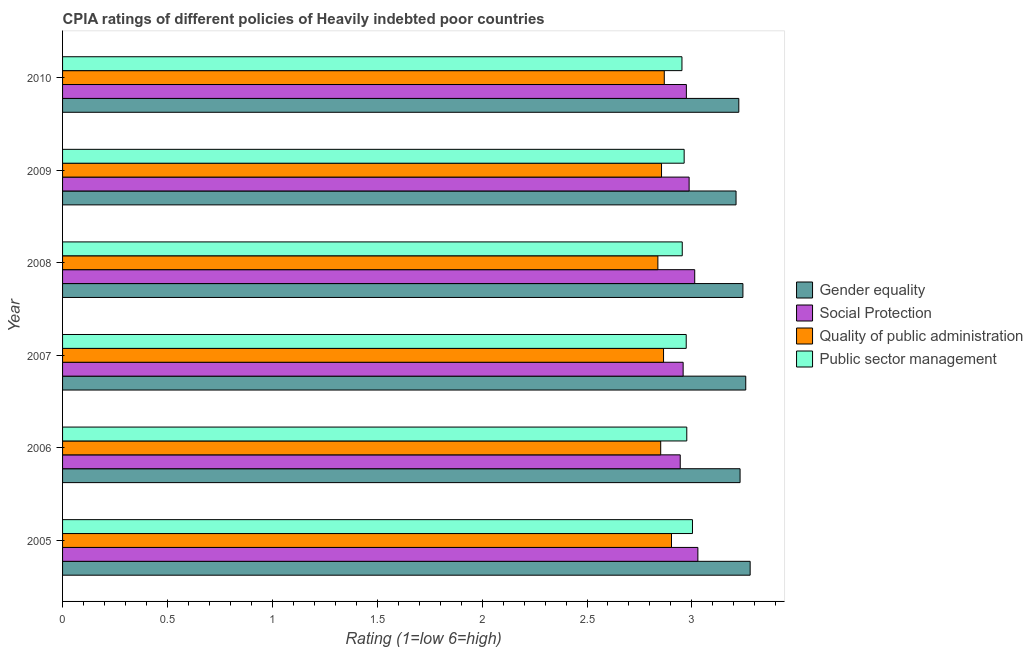How many different coloured bars are there?
Ensure brevity in your answer.  4. How many groups of bars are there?
Give a very brief answer. 6. Are the number of bars per tick equal to the number of legend labels?
Make the answer very short. Yes. How many bars are there on the 6th tick from the bottom?
Give a very brief answer. 4. What is the label of the 4th group of bars from the top?
Keep it short and to the point. 2007. In how many cases, is the number of bars for a given year not equal to the number of legend labels?
Keep it short and to the point. 0. What is the cpia rating of quality of public administration in 2010?
Ensure brevity in your answer.  2.87. Across all years, what is the maximum cpia rating of quality of public administration?
Your answer should be very brief. 2.9. Across all years, what is the minimum cpia rating of gender equality?
Your response must be concise. 3.21. In which year was the cpia rating of social protection minimum?
Give a very brief answer. 2006. What is the total cpia rating of gender equality in the graph?
Your answer should be very brief. 19.44. What is the difference between the cpia rating of quality of public administration in 2005 and that in 2008?
Keep it short and to the point. 0.07. What is the difference between the cpia rating of social protection in 2009 and the cpia rating of quality of public administration in 2005?
Offer a very short reply. 0.08. What is the average cpia rating of social protection per year?
Offer a very short reply. 2.98. In the year 2009, what is the difference between the cpia rating of gender equality and cpia rating of social protection?
Provide a succinct answer. 0.22. Is the difference between the cpia rating of gender equality in 2007 and 2010 greater than the difference between the cpia rating of public sector management in 2007 and 2010?
Your answer should be compact. Yes. What is the difference between the highest and the second highest cpia rating of social protection?
Offer a terse response. 0.01. In how many years, is the cpia rating of social protection greater than the average cpia rating of social protection taken over all years?
Give a very brief answer. 3. Is the sum of the cpia rating of quality of public administration in 2007 and 2009 greater than the maximum cpia rating of gender equality across all years?
Ensure brevity in your answer.  Yes. Is it the case that in every year, the sum of the cpia rating of gender equality and cpia rating of social protection is greater than the sum of cpia rating of public sector management and cpia rating of quality of public administration?
Offer a terse response. Yes. What does the 4th bar from the top in 2010 represents?
Your answer should be compact. Gender equality. What does the 1st bar from the bottom in 2005 represents?
Provide a succinct answer. Gender equality. How many bars are there?
Offer a very short reply. 24. Does the graph contain grids?
Keep it short and to the point. No. What is the title of the graph?
Keep it short and to the point. CPIA ratings of different policies of Heavily indebted poor countries. Does "Tracking ability" appear as one of the legend labels in the graph?
Your answer should be very brief. No. What is the label or title of the Y-axis?
Ensure brevity in your answer.  Year. What is the Rating (1=low 6=high) in Gender equality in 2005?
Your response must be concise. 3.28. What is the Rating (1=low 6=high) in Social Protection in 2005?
Your response must be concise. 3.03. What is the Rating (1=low 6=high) in Quality of public administration in 2005?
Provide a succinct answer. 2.9. What is the Rating (1=low 6=high) of Public sector management in 2005?
Keep it short and to the point. 3. What is the Rating (1=low 6=high) of Gender equality in 2006?
Provide a succinct answer. 3.23. What is the Rating (1=low 6=high) in Social Protection in 2006?
Your response must be concise. 2.94. What is the Rating (1=low 6=high) in Quality of public administration in 2006?
Offer a very short reply. 2.85. What is the Rating (1=low 6=high) of Public sector management in 2006?
Make the answer very short. 2.98. What is the Rating (1=low 6=high) in Gender equality in 2007?
Your answer should be very brief. 3.26. What is the Rating (1=low 6=high) of Social Protection in 2007?
Your answer should be very brief. 2.96. What is the Rating (1=low 6=high) of Quality of public administration in 2007?
Offer a very short reply. 2.86. What is the Rating (1=low 6=high) in Public sector management in 2007?
Your response must be concise. 2.97. What is the Rating (1=low 6=high) in Gender equality in 2008?
Provide a short and direct response. 3.24. What is the Rating (1=low 6=high) in Social Protection in 2008?
Offer a terse response. 3.01. What is the Rating (1=low 6=high) of Quality of public administration in 2008?
Give a very brief answer. 2.84. What is the Rating (1=low 6=high) in Public sector management in 2008?
Offer a terse response. 2.95. What is the Rating (1=low 6=high) in Gender equality in 2009?
Keep it short and to the point. 3.21. What is the Rating (1=low 6=high) of Social Protection in 2009?
Your answer should be very brief. 2.99. What is the Rating (1=low 6=high) in Quality of public administration in 2009?
Offer a terse response. 2.86. What is the Rating (1=low 6=high) in Public sector management in 2009?
Make the answer very short. 2.96. What is the Rating (1=low 6=high) in Gender equality in 2010?
Offer a terse response. 3.22. What is the Rating (1=low 6=high) in Social Protection in 2010?
Offer a very short reply. 2.97. What is the Rating (1=low 6=high) in Quality of public administration in 2010?
Provide a succinct answer. 2.87. What is the Rating (1=low 6=high) in Public sector management in 2010?
Ensure brevity in your answer.  2.95. Across all years, what is the maximum Rating (1=low 6=high) in Gender equality?
Ensure brevity in your answer.  3.28. Across all years, what is the maximum Rating (1=low 6=high) in Social Protection?
Provide a short and direct response. 3.03. Across all years, what is the maximum Rating (1=low 6=high) in Quality of public administration?
Provide a succinct answer. 2.9. Across all years, what is the maximum Rating (1=low 6=high) in Public sector management?
Provide a succinct answer. 3. Across all years, what is the minimum Rating (1=low 6=high) of Gender equality?
Make the answer very short. 3.21. Across all years, what is the minimum Rating (1=low 6=high) of Social Protection?
Your answer should be compact. 2.94. Across all years, what is the minimum Rating (1=low 6=high) in Quality of public administration?
Your answer should be very brief. 2.84. Across all years, what is the minimum Rating (1=low 6=high) of Public sector management?
Your answer should be very brief. 2.95. What is the total Rating (1=low 6=high) in Gender equality in the graph?
Offer a very short reply. 19.44. What is the total Rating (1=low 6=high) of Social Protection in the graph?
Ensure brevity in your answer.  17.91. What is the total Rating (1=low 6=high) in Quality of public administration in the graph?
Offer a terse response. 17.18. What is the total Rating (1=low 6=high) of Public sector management in the graph?
Offer a very short reply. 17.82. What is the difference between the Rating (1=low 6=high) in Gender equality in 2005 and that in 2006?
Give a very brief answer. 0.05. What is the difference between the Rating (1=low 6=high) of Social Protection in 2005 and that in 2006?
Keep it short and to the point. 0.08. What is the difference between the Rating (1=low 6=high) in Quality of public administration in 2005 and that in 2006?
Keep it short and to the point. 0.05. What is the difference between the Rating (1=low 6=high) in Public sector management in 2005 and that in 2006?
Provide a succinct answer. 0.03. What is the difference between the Rating (1=low 6=high) of Gender equality in 2005 and that in 2007?
Provide a succinct answer. 0.02. What is the difference between the Rating (1=low 6=high) of Social Protection in 2005 and that in 2007?
Give a very brief answer. 0.07. What is the difference between the Rating (1=low 6=high) of Quality of public administration in 2005 and that in 2007?
Offer a very short reply. 0.04. What is the difference between the Rating (1=low 6=high) of Public sector management in 2005 and that in 2007?
Offer a terse response. 0.03. What is the difference between the Rating (1=low 6=high) of Gender equality in 2005 and that in 2008?
Provide a short and direct response. 0.03. What is the difference between the Rating (1=low 6=high) of Social Protection in 2005 and that in 2008?
Keep it short and to the point. 0.02. What is the difference between the Rating (1=low 6=high) of Quality of public administration in 2005 and that in 2008?
Your answer should be very brief. 0.06. What is the difference between the Rating (1=low 6=high) in Public sector management in 2005 and that in 2008?
Your response must be concise. 0.05. What is the difference between the Rating (1=low 6=high) of Gender equality in 2005 and that in 2009?
Offer a very short reply. 0.07. What is the difference between the Rating (1=low 6=high) in Social Protection in 2005 and that in 2009?
Keep it short and to the point. 0.04. What is the difference between the Rating (1=low 6=high) of Quality of public administration in 2005 and that in 2009?
Your response must be concise. 0.05. What is the difference between the Rating (1=low 6=high) in Public sector management in 2005 and that in 2009?
Provide a short and direct response. 0.04. What is the difference between the Rating (1=low 6=high) in Gender equality in 2005 and that in 2010?
Give a very brief answer. 0.05. What is the difference between the Rating (1=low 6=high) in Social Protection in 2005 and that in 2010?
Provide a short and direct response. 0.05. What is the difference between the Rating (1=low 6=high) in Quality of public administration in 2005 and that in 2010?
Ensure brevity in your answer.  0.03. What is the difference between the Rating (1=low 6=high) in Public sector management in 2005 and that in 2010?
Give a very brief answer. 0.05. What is the difference between the Rating (1=low 6=high) of Gender equality in 2006 and that in 2007?
Provide a short and direct response. -0.03. What is the difference between the Rating (1=low 6=high) in Social Protection in 2006 and that in 2007?
Your response must be concise. -0.01. What is the difference between the Rating (1=low 6=high) in Quality of public administration in 2006 and that in 2007?
Ensure brevity in your answer.  -0.01. What is the difference between the Rating (1=low 6=high) in Public sector management in 2006 and that in 2007?
Offer a terse response. 0. What is the difference between the Rating (1=low 6=high) in Gender equality in 2006 and that in 2008?
Give a very brief answer. -0.01. What is the difference between the Rating (1=low 6=high) in Social Protection in 2006 and that in 2008?
Offer a very short reply. -0.07. What is the difference between the Rating (1=low 6=high) of Quality of public administration in 2006 and that in 2008?
Offer a terse response. 0.01. What is the difference between the Rating (1=low 6=high) of Public sector management in 2006 and that in 2008?
Offer a terse response. 0.02. What is the difference between the Rating (1=low 6=high) of Gender equality in 2006 and that in 2009?
Your response must be concise. 0.02. What is the difference between the Rating (1=low 6=high) in Social Protection in 2006 and that in 2009?
Give a very brief answer. -0.04. What is the difference between the Rating (1=low 6=high) in Quality of public administration in 2006 and that in 2009?
Your response must be concise. -0. What is the difference between the Rating (1=low 6=high) of Public sector management in 2006 and that in 2009?
Keep it short and to the point. 0.01. What is the difference between the Rating (1=low 6=high) of Gender equality in 2006 and that in 2010?
Give a very brief answer. 0.01. What is the difference between the Rating (1=low 6=high) of Social Protection in 2006 and that in 2010?
Make the answer very short. -0.03. What is the difference between the Rating (1=low 6=high) in Quality of public administration in 2006 and that in 2010?
Make the answer very short. -0.02. What is the difference between the Rating (1=low 6=high) of Public sector management in 2006 and that in 2010?
Keep it short and to the point. 0.02. What is the difference between the Rating (1=low 6=high) in Gender equality in 2007 and that in 2008?
Your response must be concise. 0.01. What is the difference between the Rating (1=low 6=high) of Social Protection in 2007 and that in 2008?
Keep it short and to the point. -0.06. What is the difference between the Rating (1=low 6=high) of Quality of public administration in 2007 and that in 2008?
Ensure brevity in your answer.  0.03. What is the difference between the Rating (1=low 6=high) of Public sector management in 2007 and that in 2008?
Your answer should be compact. 0.02. What is the difference between the Rating (1=low 6=high) in Gender equality in 2007 and that in 2009?
Give a very brief answer. 0.05. What is the difference between the Rating (1=low 6=high) in Social Protection in 2007 and that in 2009?
Provide a succinct answer. -0.03. What is the difference between the Rating (1=low 6=high) of Quality of public administration in 2007 and that in 2009?
Keep it short and to the point. 0.01. What is the difference between the Rating (1=low 6=high) in Public sector management in 2007 and that in 2009?
Offer a very short reply. 0.01. What is the difference between the Rating (1=low 6=high) of Gender equality in 2007 and that in 2010?
Keep it short and to the point. 0.03. What is the difference between the Rating (1=low 6=high) in Social Protection in 2007 and that in 2010?
Make the answer very short. -0.02. What is the difference between the Rating (1=low 6=high) in Quality of public administration in 2007 and that in 2010?
Your answer should be very brief. -0. What is the difference between the Rating (1=low 6=high) of Public sector management in 2007 and that in 2010?
Your answer should be compact. 0.02. What is the difference between the Rating (1=low 6=high) in Gender equality in 2008 and that in 2009?
Offer a terse response. 0.03. What is the difference between the Rating (1=low 6=high) in Social Protection in 2008 and that in 2009?
Provide a succinct answer. 0.03. What is the difference between the Rating (1=low 6=high) in Quality of public administration in 2008 and that in 2009?
Provide a succinct answer. -0.02. What is the difference between the Rating (1=low 6=high) of Public sector management in 2008 and that in 2009?
Your response must be concise. -0.01. What is the difference between the Rating (1=low 6=high) of Gender equality in 2008 and that in 2010?
Offer a terse response. 0.02. What is the difference between the Rating (1=low 6=high) in Social Protection in 2008 and that in 2010?
Your response must be concise. 0.04. What is the difference between the Rating (1=low 6=high) in Quality of public administration in 2008 and that in 2010?
Provide a short and direct response. -0.03. What is the difference between the Rating (1=low 6=high) in Public sector management in 2008 and that in 2010?
Keep it short and to the point. 0. What is the difference between the Rating (1=low 6=high) of Gender equality in 2009 and that in 2010?
Your answer should be very brief. -0.01. What is the difference between the Rating (1=low 6=high) of Social Protection in 2009 and that in 2010?
Your answer should be very brief. 0.01. What is the difference between the Rating (1=low 6=high) in Quality of public administration in 2009 and that in 2010?
Make the answer very short. -0.01. What is the difference between the Rating (1=low 6=high) of Public sector management in 2009 and that in 2010?
Your response must be concise. 0.01. What is the difference between the Rating (1=low 6=high) in Gender equality in 2005 and the Rating (1=low 6=high) in Quality of public administration in 2006?
Keep it short and to the point. 0.43. What is the difference between the Rating (1=low 6=high) of Gender equality in 2005 and the Rating (1=low 6=high) of Public sector management in 2006?
Keep it short and to the point. 0.3. What is the difference between the Rating (1=low 6=high) of Social Protection in 2005 and the Rating (1=low 6=high) of Quality of public administration in 2006?
Make the answer very short. 0.18. What is the difference between the Rating (1=low 6=high) of Social Protection in 2005 and the Rating (1=low 6=high) of Public sector management in 2006?
Your response must be concise. 0.05. What is the difference between the Rating (1=low 6=high) of Quality of public administration in 2005 and the Rating (1=low 6=high) of Public sector management in 2006?
Give a very brief answer. -0.07. What is the difference between the Rating (1=low 6=high) in Gender equality in 2005 and the Rating (1=low 6=high) in Social Protection in 2007?
Offer a terse response. 0.32. What is the difference between the Rating (1=low 6=high) of Gender equality in 2005 and the Rating (1=low 6=high) of Quality of public administration in 2007?
Your response must be concise. 0.41. What is the difference between the Rating (1=low 6=high) of Gender equality in 2005 and the Rating (1=low 6=high) of Public sector management in 2007?
Provide a short and direct response. 0.3. What is the difference between the Rating (1=low 6=high) of Social Protection in 2005 and the Rating (1=low 6=high) of Quality of public administration in 2007?
Your answer should be very brief. 0.16. What is the difference between the Rating (1=low 6=high) of Social Protection in 2005 and the Rating (1=low 6=high) of Public sector management in 2007?
Your answer should be compact. 0.06. What is the difference between the Rating (1=low 6=high) of Quality of public administration in 2005 and the Rating (1=low 6=high) of Public sector management in 2007?
Make the answer very short. -0.07. What is the difference between the Rating (1=low 6=high) of Gender equality in 2005 and the Rating (1=low 6=high) of Social Protection in 2008?
Your response must be concise. 0.26. What is the difference between the Rating (1=low 6=high) in Gender equality in 2005 and the Rating (1=low 6=high) in Quality of public administration in 2008?
Provide a succinct answer. 0.44. What is the difference between the Rating (1=low 6=high) in Gender equality in 2005 and the Rating (1=low 6=high) in Public sector management in 2008?
Make the answer very short. 0.32. What is the difference between the Rating (1=low 6=high) in Social Protection in 2005 and the Rating (1=low 6=high) in Quality of public administration in 2008?
Provide a succinct answer. 0.19. What is the difference between the Rating (1=low 6=high) of Social Protection in 2005 and the Rating (1=low 6=high) of Public sector management in 2008?
Your response must be concise. 0.07. What is the difference between the Rating (1=low 6=high) of Quality of public administration in 2005 and the Rating (1=low 6=high) of Public sector management in 2008?
Give a very brief answer. -0.05. What is the difference between the Rating (1=low 6=high) in Gender equality in 2005 and the Rating (1=low 6=high) in Social Protection in 2009?
Offer a very short reply. 0.29. What is the difference between the Rating (1=low 6=high) in Gender equality in 2005 and the Rating (1=low 6=high) in Quality of public administration in 2009?
Offer a terse response. 0.42. What is the difference between the Rating (1=low 6=high) of Gender equality in 2005 and the Rating (1=low 6=high) of Public sector management in 2009?
Provide a succinct answer. 0.31. What is the difference between the Rating (1=low 6=high) of Social Protection in 2005 and the Rating (1=low 6=high) of Quality of public administration in 2009?
Offer a terse response. 0.17. What is the difference between the Rating (1=low 6=high) of Social Protection in 2005 and the Rating (1=low 6=high) of Public sector management in 2009?
Keep it short and to the point. 0.07. What is the difference between the Rating (1=low 6=high) in Quality of public administration in 2005 and the Rating (1=low 6=high) in Public sector management in 2009?
Make the answer very short. -0.06. What is the difference between the Rating (1=low 6=high) of Gender equality in 2005 and the Rating (1=low 6=high) of Social Protection in 2010?
Keep it short and to the point. 0.3. What is the difference between the Rating (1=low 6=high) of Gender equality in 2005 and the Rating (1=low 6=high) of Quality of public administration in 2010?
Keep it short and to the point. 0.41. What is the difference between the Rating (1=low 6=high) in Gender equality in 2005 and the Rating (1=low 6=high) in Public sector management in 2010?
Ensure brevity in your answer.  0.33. What is the difference between the Rating (1=low 6=high) of Social Protection in 2005 and the Rating (1=low 6=high) of Quality of public administration in 2010?
Your answer should be compact. 0.16. What is the difference between the Rating (1=low 6=high) in Social Protection in 2005 and the Rating (1=low 6=high) in Public sector management in 2010?
Your answer should be very brief. 0.08. What is the difference between the Rating (1=low 6=high) in Quality of public administration in 2005 and the Rating (1=low 6=high) in Public sector management in 2010?
Ensure brevity in your answer.  -0.05. What is the difference between the Rating (1=low 6=high) of Gender equality in 2006 and the Rating (1=low 6=high) of Social Protection in 2007?
Ensure brevity in your answer.  0.27. What is the difference between the Rating (1=low 6=high) in Gender equality in 2006 and the Rating (1=low 6=high) in Quality of public administration in 2007?
Offer a very short reply. 0.36. What is the difference between the Rating (1=low 6=high) in Gender equality in 2006 and the Rating (1=low 6=high) in Public sector management in 2007?
Provide a succinct answer. 0.26. What is the difference between the Rating (1=low 6=high) in Social Protection in 2006 and the Rating (1=low 6=high) in Quality of public administration in 2007?
Make the answer very short. 0.08. What is the difference between the Rating (1=low 6=high) of Social Protection in 2006 and the Rating (1=low 6=high) of Public sector management in 2007?
Offer a terse response. -0.03. What is the difference between the Rating (1=low 6=high) of Quality of public administration in 2006 and the Rating (1=low 6=high) of Public sector management in 2007?
Your response must be concise. -0.12. What is the difference between the Rating (1=low 6=high) of Gender equality in 2006 and the Rating (1=low 6=high) of Social Protection in 2008?
Keep it short and to the point. 0.22. What is the difference between the Rating (1=low 6=high) in Gender equality in 2006 and the Rating (1=low 6=high) in Quality of public administration in 2008?
Offer a terse response. 0.39. What is the difference between the Rating (1=low 6=high) in Gender equality in 2006 and the Rating (1=low 6=high) in Public sector management in 2008?
Provide a succinct answer. 0.28. What is the difference between the Rating (1=low 6=high) of Social Protection in 2006 and the Rating (1=low 6=high) of Quality of public administration in 2008?
Give a very brief answer. 0.11. What is the difference between the Rating (1=low 6=high) in Social Protection in 2006 and the Rating (1=low 6=high) in Public sector management in 2008?
Keep it short and to the point. -0.01. What is the difference between the Rating (1=low 6=high) of Quality of public administration in 2006 and the Rating (1=low 6=high) of Public sector management in 2008?
Your response must be concise. -0.1. What is the difference between the Rating (1=low 6=high) of Gender equality in 2006 and the Rating (1=low 6=high) of Social Protection in 2009?
Provide a short and direct response. 0.24. What is the difference between the Rating (1=low 6=high) in Gender equality in 2006 and the Rating (1=low 6=high) in Quality of public administration in 2009?
Give a very brief answer. 0.37. What is the difference between the Rating (1=low 6=high) of Gender equality in 2006 and the Rating (1=low 6=high) of Public sector management in 2009?
Your response must be concise. 0.27. What is the difference between the Rating (1=low 6=high) in Social Protection in 2006 and the Rating (1=low 6=high) in Quality of public administration in 2009?
Give a very brief answer. 0.09. What is the difference between the Rating (1=low 6=high) of Social Protection in 2006 and the Rating (1=low 6=high) of Public sector management in 2009?
Your response must be concise. -0.02. What is the difference between the Rating (1=low 6=high) in Quality of public administration in 2006 and the Rating (1=low 6=high) in Public sector management in 2009?
Your response must be concise. -0.11. What is the difference between the Rating (1=low 6=high) of Gender equality in 2006 and the Rating (1=low 6=high) of Social Protection in 2010?
Give a very brief answer. 0.26. What is the difference between the Rating (1=low 6=high) in Gender equality in 2006 and the Rating (1=low 6=high) in Quality of public administration in 2010?
Make the answer very short. 0.36. What is the difference between the Rating (1=low 6=high) in Gender equality in 2006 and the Rating (1=low 6=high) in Public sector management in 2010?
Your response must be concise. 0.28. What is the difference between the Rating (1=low 6=high) in Social Protection in 2006 and the Rating (1=low 6=high) in Quality of public administration in 2010?
Offer a terse response. 0.08. What is the difference between the Rating (1=low 6=high) of Social Protection in 2006 and the Rating (1=low 6=high) of Public sector management in 2010?
Provide a short and direct response. -0.01. What is the difference between the Rating (1=low 6=high) in Quality of public administration in 2006 and the Rating (1=low 6=high) in Public sector management in 2010?
Offer a terse response. -0.1. What is the difference between the Rating (1=low 6=high) in Gender equality in 2007 and the Rating (1=low 6=high) in Social Protection in 2008?
Provide a succinct answer. 0.24. What is the difference between the Rating (1=low 6=high) in Gender equality in 2007 and the Rating (1=low 6=high) in Quality of public administration in 2008?
Provide a short and direct response. 0.42. What is the difference between the Rating (1=low 6=high) in Gender equality in 2007 and the Rating (1=low 6=high) in Public sector management in 2008?
Offer a terse response. 0.3. What is the difference between the Rating (1=low 6=high) in Social Protection in 2007 and the Rating (1=low 6=high) in Quality of public administration in 2008?
Offer a terse response. 0.12. What is the difference between the Rating (1=low 6=high) in Social Protection in 2007 and the Rating (1=low 6=high) in Public sector management in 2008?
Offer a very short reply. 0. What is the difference between the Rating (1=low 6=high) of Quality of public administration in 2007 and the Rating (1=low 6=high) of Public sector management in 2008?
Make the answer very short. -0.09. What is the difference between the Rating (1=low 6=high) of Gender equality in 2007 and the Rating (1=low 6=high) of Social Protection in 2009?
Give a very brief answer. 0.27. What is the difference between the Rating (1=low 6=high) in Gender equality in 2007 and the Rating (1=low 6=high) in Quality of public administration in 2009?
Give a very brief answer. 0.4. What is the difference between the Rating (1=low 6=high) of Gender equality in 2007 and the Rating (1=low 6=high) of Public sector management in 2009?
Your answer should be compact. 0.29. What is the difference between the Rating (1=low 6=high) of Social Protection in 2007 and the Rating (1=low 6=high) of Quality of public administration in 2009?
Ensure brevity in your answer.  0.1. What is the difference between the Rating (1=low 6=high) in Social Protection in 2007 and the Rating (1=low 6=high) in Public sector management in 2009?
Ensure brevity in your answer.  -0. What is the difference between the Rating (1=low 6=high) in Quality of public administration in 2007 and the Rating (1=low 6=high) in Public sector management in 2009?
Provide a short and direct response. -0.1. What is the difference between the Rating (1=low 6=high) of Gender equality in 2007 and the Rating (1=low 6=high) of Social Protection in 2010?
Provide a succinct answer. 0.28. What is the difference between the Rating (1=low 6=high) in Gender equality in 2007 and the Rating (1=low 6=high) in Quality of public administration in 2010?
Your response must be concise. 0.39. What is the difference between the Rating (1=low 6=high) of Gender equality in 2007 and the Rating (1=low 6=high) of Public sector management in 2010?
Your answer should be compact. 0.3. What is the difference between the Rating (1=low 6=high) in Social Protection in 2007 and the Rating (1=low 6=high) in Quality of public administration in 2010?
Your answer should be very brief. 0.09. What is the difference between the Rating (1=low 6=high) in Social Protection in 2007 and the Rating (1=low 6=high) in Public sector management in 2010?
Ensure brevity in your answer.  0.01. What is the difference between the Rating (1=low 6=high) of Quality of public administration in 2007 and the Rating (1=low 6=high) of Public sector management in 2010?
Offer a very short reply. -0.09. What is the difference between the Rating (1=low 6=high) in Gender equality in 2008 and the Rating (1=low 6=high) in Social Protection in 2009?
Provide a succinct answer. 0.26. What is the difference between the Rating (1=low 6=high) in Gender equality in 2008 and the Rating (1=low 6=high) in Quality of public administration in 2009?
Provide a short and direct response. 0.39. What is the difference between the Rating (1=low 6=high) in Gender equality in 2008 and the Rating (1=low 6=high) in Public sector management in 2009?
Your answer should be very brief. 0.28. What is the difference between the Rating (1=low 6=high) in Social Protection in 2008 and the Rating (1=low 6=high) in Quality of public administration in 2009?
Offer a terse response. 0.16. What is the difference between the Rating (1=low 6=high) of Social Protection in 2008 and the Rating (1=low 6=high) of Public sector management in 2009?
Your response must be concise. 0.05. What is the difference between the Rating (1=low 6=high) of Quality of public administration in 2008 and the Rating (1=low 6=high) of Public sector management in 2009?
Make the answer very short. -0.13. What is the difference between the Rating (1=low 6=high) of Gender equality in 2008 and the Rating (1=low 6=high) of Social Protection in 2010?
Provide a short and direct response. 0.27. What is the difference between the Rating (1=low 6=high) in Gender equality in 2008 and the Rating (1=low 6=high) in Quality of public administration in 2010?
Offer a very short reply. 0.37. What is the difference between the Rating (1=low 6=high) in Gender equality in 2008 and the Rating (1=low 6=high) in Public sector management in 2010?
Your answer should be very brief. 0.29. What is the difference between the Rating (1=low 6=high) in Social Protection in 2008 and the Rating (1=low 6=high) in Quality of public administration in 2010?
Your response must be concise. 0.15. What is the difference between the Rating (1=low 6=high) in Social Protection in 2008 and the Rating (1=low 6=high) in Public sector management in 2010?
Your answer should be compact. 0.06. What is the difference between the Rating (1=low 6=high) in Quality of public administration in 2008 and the Rating (1=low 6=high) in Public sector management in 2010?
Your response must be concise. -0.11. What is the difference between the Rating (1=low 6=high) in Gender equality in 2009 and the Rating (1=low 6=high) in Social Protection in 2010?
Your answer should be compact. 0.24. What is the difference between the Rating (1=low 6=high) of Gender equality in 2009 and the Rating (1=low 6=high) of Quality of public administration in 2010?
Offer a terse response. 0.34. What is the difference between the Rating (1=low 6=high) of Gender equality in 2009 and the Rating (1=low 6=high) of Public sector management in 2010?
Give a very brief answer. 0.26. What is the difference between the Rating (1=low 6=high) in Social Protection in 2009 and the Rating (1=low 6=high) in Quality of public administration in 2010?
Make the answer very short. 0.12. What is the difference between the Rating (1=low 6=high) of Social Protection in 2009 and the Rating (1=low 6=high) of Public sector management in 2010?
Make the answer very short. 0.03. What is the difference between the Rating (1=low 6=high) of Quality of public administration in 2009 and the Rating (1=low 6=high) of Public sector management in 2010?
Provide a short and direct response. -0.1. What is the average Rating (1=low 6=high) of Gender equality per year?
Keep it short and to the point. 3.24. What is the average Rating (1=low 6=high) in Social Protection per year?
Ensure brevity in your answer.  2.98. What is the average Rating (1=low 6=high) in Quality of public administration per year?
Your response must be concise. 2.86. What is the average Rating (1=low 6=high) of Public sector management per year?
Offer a very short reply. 2.97. In the year 2005, what is the difference between the Rating (1=low 6=high) of Gender equality and Rating (1=low 6=high) of Social Protection?
Offer a very short reply. 0.25. In the year 2005, what is the difference between the Rating (1=low 6=high) in Gender equality and Rating (1=low 6=high) in Public sector management?
Your response must be concise. 0.28. In the year 2005, what is the difference between the Rating (1=low 6=high) of Social Protection and Rating (1=low 6=high) of Quality of public administration?
Your answer should be compact. 0.13. In the year 2005, what is the difference between the Rating (1=low 6=high) of Social Protection and Rating (1=low 6=high) of Public sector management?
Your answer should be very brief. 0.03. In the year 2005, what is the difference between the Rating (1=low 6=high) of Quality of public administration and Rating (1=low 6=high) of Public sector management?
Provide a succinct answer. -0.1. In the year 2006, what is the difference between the Rating (1=low 6=high) in Gender equality and Rating (1=low 6=high) in Social Protection?
Your answer should be compact. 0.29. In the year 2006, what is the difference between the Rating (1=low 6=high) in Gender equality and Rating (1=low 6=high) in Quality of public administration?
Your answer should be compact. 0.38. In the year 2006, what is the difference between the Rating (1=low 6=high) in Gender equality and Rating (1=low 6=high) in Public sector management?
Ensure brevity in your answer.  0.25. In the year 2006, what is the difference between the Rating (1=low 6=high) in Social Protection and Rating (1=low 6=high) in Quality of public administration?
Make the answer very short. 0.09. In the year 2006, what is the difference between the Rating (1=low 6=high) in Social Protection and Rating (1=low 6=high) in Public sector management?
Offer a terse response. -0.03. In the year 2006, what is the difference between the Rating (1=low 6=high) of Quality of public administration and Rating (1=low 6=high) of Public sector management?
Your answer should be compact. -0.12. In the year 2007, what is the difference between the Rating (1=low 6=high) of Gender equality and Rating (1=low 6=high) of Social Protection?
Your answer should be very brief. 0.3. In the year 2007, what is the difference between the Rating (1=low 6=high) in Gender equality and Rating (1=low 6=high) in Quality of public administration?
Your answer should be very brief. 0.39. In the year 2007, what is the difference between the Rating (1=low 6=high) of Gender equality and Rating (1=low 6=high) of Public sector management?
Your response must be concise. 0.28. In the year 2007, what is the difference between the Rating (1=low 6=high) in Social Protection and Rating (1=low 6=high) in Quality of public administration?
Make the answer very short. 0.09. In the year 2007, what is the difference between the Rating (1=low 6=high) of Social Protection and Rating (1=low 6=high) of Public sector management?
Ensure brevity in your answer.  -0.01. In the year 2007, what is the difference between the Rating (1=low 6=high) in Quality of public administration and Rating (1=low 6=high) in Public sector management?
Your answer should be very brief. -0.11. In the year 2008, what is the difference between the Rating (1=low 6=high) of Gender equality and Rating (1=low 6=high) of Social Protection?
Your answer should be compact. 0.23. In the year 2008, what is the difference between the Rating (1=low 6=high) of Gender equality and Rating (1=low 6=high) of Quality of public administration?
Provide a succinct answer. 0.41. In the year 2008, what is the difference between the Rating (1=low 6=high) of Gender equality and Rating (1=low 6=high) of Public sector management?
Your response must be concise. 0.29. In the year 2008, what is the difference between the Rating (1=low 6=high) in Social Protection and Rating (1=low 6=high) in Quality of public administration?
Keep it short and to the point. 0.18. In the year 2008, what is the difference between the Rating (1=low 6=high) of Social Protection and Rating (1=low 6=high) of Public sector management?
Offer a terse response. 0.06. In the year 2008, what is the difference between the Rating (1=low 6=high) in Quality of public administration and Rating (1=low 6=high) in Public sector management?
Keep it short and to the point. -0.12. In the year 2009, what is the difference between the Rating (1=low 6=high) of Gender equality and Rating (1=low 6=high) of Social Protection?
Make the answer very short. 0.22. In the year 2009, what is the difference between the Rating (1=low 6=high) in Gender equality and Rating (1=low 6=high) in Quality of public administration?
Keep it short and to the point. 0.36. In the year 2009, what is the difference between the Rating (1=low 6=high) of Gender equality and Rating (1=low 6=high) of Public sector management?
Give a very brief answer. 0.25. In the year 2009, what is the difference between the Rating (1=low 6=high) of Social Protection and Rating (1=low 6=high) of Quality of public administration?
Your answer should be very brief. 0.13. In the year 2009, what is the difference between the Rating (1=low 6=high) in Social Protection and Rating (1=low 6=high) in Public sector management?
Make the answer very short. 0.02. In the year 2009, what is the difference between the Rating (1=low 6=high) of Quality of public administration and Rating (1=low 6=high) of Public sector management?
Your answer should be very brief. -0.11. In the year 2010, what is the difference between the Rating (1=low 6=high) in Gender equality and Rating (1=low 6=high) in Quality of public administration?
Your response must be concise. 0.36. In the year 2010, what is the difference between the Rating (1=low 6=high) in Gender equality and Rating (1=low 6=high) in Public sector management?
Keep it short and to the point. 0.27. In the year 2010, what is the difference between the Rating (1=low 6=high) in Social Protection and Rating (1=low 6=high) in Quality of public administration?
Ensure brevity in your answer.  0.11. In the year 2010, what is the difference between the Rating (1=low 6=high) in Social Protection and Rating (1=low 6=high) in Public sector management?
Ensure brevity in your answer.  0.02. In the year 2010, what is the difference between the Rating (1=low 6=high) in Quality of public administration and Rating (1=low 6=high) in Public sector management?
Ensure brevity in your answer.  -0.08. What is the ratio of the Rating (1=low 6=high) in Gender equality in 2005 to that in 2006?
Provide a short and direct response. 1.01. What is the ratio of the Rating (1=low 6=high) in Social Protection in 2005 to that in 2006?
Provide a succinct answer. 1.03. What is the ratio of the Rating (1=low 6=high) in Public sector management in 2005 to that in 2006?
Give a very brief answer. 1.01. What is the ratio of the Rating (1=low 6=high) of Social Protection in 2005 to that in 2007?
Keep it short and to the point. 1.02. What is the ratio of the Rating (1=low 6=high) in Quality of public administration in 2005 to that in 2007?
Provide a short and direct response. 1.01. What is the ratio of the Rating (1=low 6=high) in Public sector management in 2005 to that in 2007?
Your answer should be very brief. 1.01. What is the ratio of the Rating (1=low 6=high) in Gender equality in 2005 to that in 2008?
Keep it short and to the point. 1.01. What is the ratio of the Rating (1=low 6=high) in Social Protection in 2005 to that in 2008?
Offer a very short reply. 1. What is the ratio of the Rating (1=low 6=high) in Quality of public administration in 2005 to that in 2008?
Keep it short and to the point. 1.02. What is the ratio of the Rating (1=low 6=high) in Public sector management in 2005 to that in 2008?
Offer a terse response. 1.02. What is the ratio of the Rating (1=low 6=high) in Gender equality in 2005 to that in 2009?
Give a very brief answer. 1.02. What is the ratio of the Rating (1=low 6=high) of Social Protection in 2005 to that in 2009?
Provide a short and direct response. 1.01. What is the ratio of the Rating (1=low 6=high) in Quality of public administration in 2005 to that in 2009?
Offer a very short reply. 1.02. What is the ratio of the Rating (1=low 6=high) of Public sector management in 2005 to that in 2009?
Keep it short and to the point. 1.01. What is the ratio of the Rating (1=low 6=high) of Gender equality in 2005 to that in 2010?
Your answer should be very brief. 1.02. What is the ratio of the Rating (1=low 6=high) in Social Protection in 2005 to that in 2010?
Your response must be concise. 1.02. What is the ratio of the Rating (1=low 6=high) of Quality of public administration in 2005 to that in 2010?
Provide a succinct answer. 1.01. What is the ratio of the Rating (1=low 6=high) in Public sector management in 2005 to that in 2010?
Your answer should be very brief. 1.02. What is the ratio of the Rating (1=low 6=high) of Gender equality in 2006 to that in 2007?
Give a very brief answer. 0.99. What is the ratio of the Rating (1=low 6=high) of Public sector management in 2006 to that in 2007?
Provide a short and direct response. 1. What is the ratio of the Rating (1=low 6=high) of Social Protection in 2006 to that in 2008?
Your answer should be very brief. 0.98. What is the ratio of the Rating (1=low 6=high) of Public sector management in 2006 to that in 2008?
Offer a very short reply. 1.01. What is the ratio of the Rating (1=low 6=high) in Social Protection in 2006 to that in 2009?
Provide a succinct answer. 0.99. What is the ratio of the Rating (1=low 6=high) of Social Protection in 2006 to that in 2010?
Your answer should be very brief. 0.99. What is the ratio of the Rating (1=low 6=high) in Public sector management in 2006 to that in 2010?
Your response must be concise. 1.01. What is the ratio of the Rating (1=low 6=high) of Social Protection in 2007 to that in 2008?
Your answer should be very brief. 0.98. What is the ratio of the Rating (1=low 6=high) in Quality of public administration in 2007 to that in 2008?
Ensure brevity in your answer.  1.01. What is the ratio of the Rating (1=low 6=high) in Public sector management in 2007 to that in 2008?
Give a very brief answer. 1.01. What is the ratio of the Rating (1=low 6=high) of Gender equality in 2007 to that in 2009?
Provide a short and direct response. 1.01. What is the ratio of the Rating (1=low 6=high) in Quality of public administration in 2007 to that in 2009?
Give a very brief answer. 1. What is the ratio of the Rating (1=low 6=high) of Gender equality in 2007 to that in 2010?
Offer a very short reply. 1.01. What is the ratio of the Rating (1=low 6=high) of Social Protection in 2007 to that in 2010?
Your answer should be compact. 0.99. What is the ratio of the Rating (1=low 6=high) in Quality of public administration in 2007 to that in 2010?
Provide a succinct answer. 1. What is the ratio of the Rating (1=low 6=high) in Gender equality in 2008 to that in 2009?
Offer a terse response. 1.01. What is the ratio of the Rating (1=low 6=high) in Social Protection in 2008 to that in 2009?
Offer a terse response. 1.01. What is the ratio of the Rating (1=low 6=high) in Gender equality in 2008 to that in 2010?
Ensure brevity in your answer.  1.01. What is the ratio of the Rating (1=low 6=high) in Social Protection in 2008 to that in 2010?
Give a very brief answer. 1.01. What is the ratio of the Rating (1=low 6=high) of Quality of public administration in 2008 to that in 2010?
Your answer should be very brief. 0.99. What is the ratio of the Rating (1=low 6=high) in Gender equality in 2009 to that in 2010?
Ensure brevity in your answer.  1. What is the ratio of the Rating (1=low 6=high) of Quality of public administration in 2009 to that in 2010?
Provide a short and direct response. 1. What is the difference between the highest and the second highest Rating (1=low 6=high) of Gender equality?
Offer a very short reply. 0.02. What is the difference between the highest and the second highest Rating (1=low 6=high) of Social Protection?
Make the answer very short. 0.02. What is the difference between the highest and the second highest Rating (1=low 6=high) of Quality of public administration?
Offer a very short reply. 0.03. What is the difference between the highest and the second highest Rating (1=low 6=high) in Public sector management?
Your answer should be very brief. 0.03. What is the difference between the highest and the lowest Rating (1=low 6=high) of Gender equality?
Ensure brevity in your answer.  0.07. What is the difference between the highest and the lowest Rating (1=low 6=high) in Social Protection?
Your response must be concise. 0.08. What is the difference between the highest and the lowest Rating (1=low 6=high) of Quality of public administration?
Provide a short and direct response. 0.06. What is the difference between the highest and the lowest Rating (1=low 6=high) of Public sector management?
Make the answer very short. 0.05. 